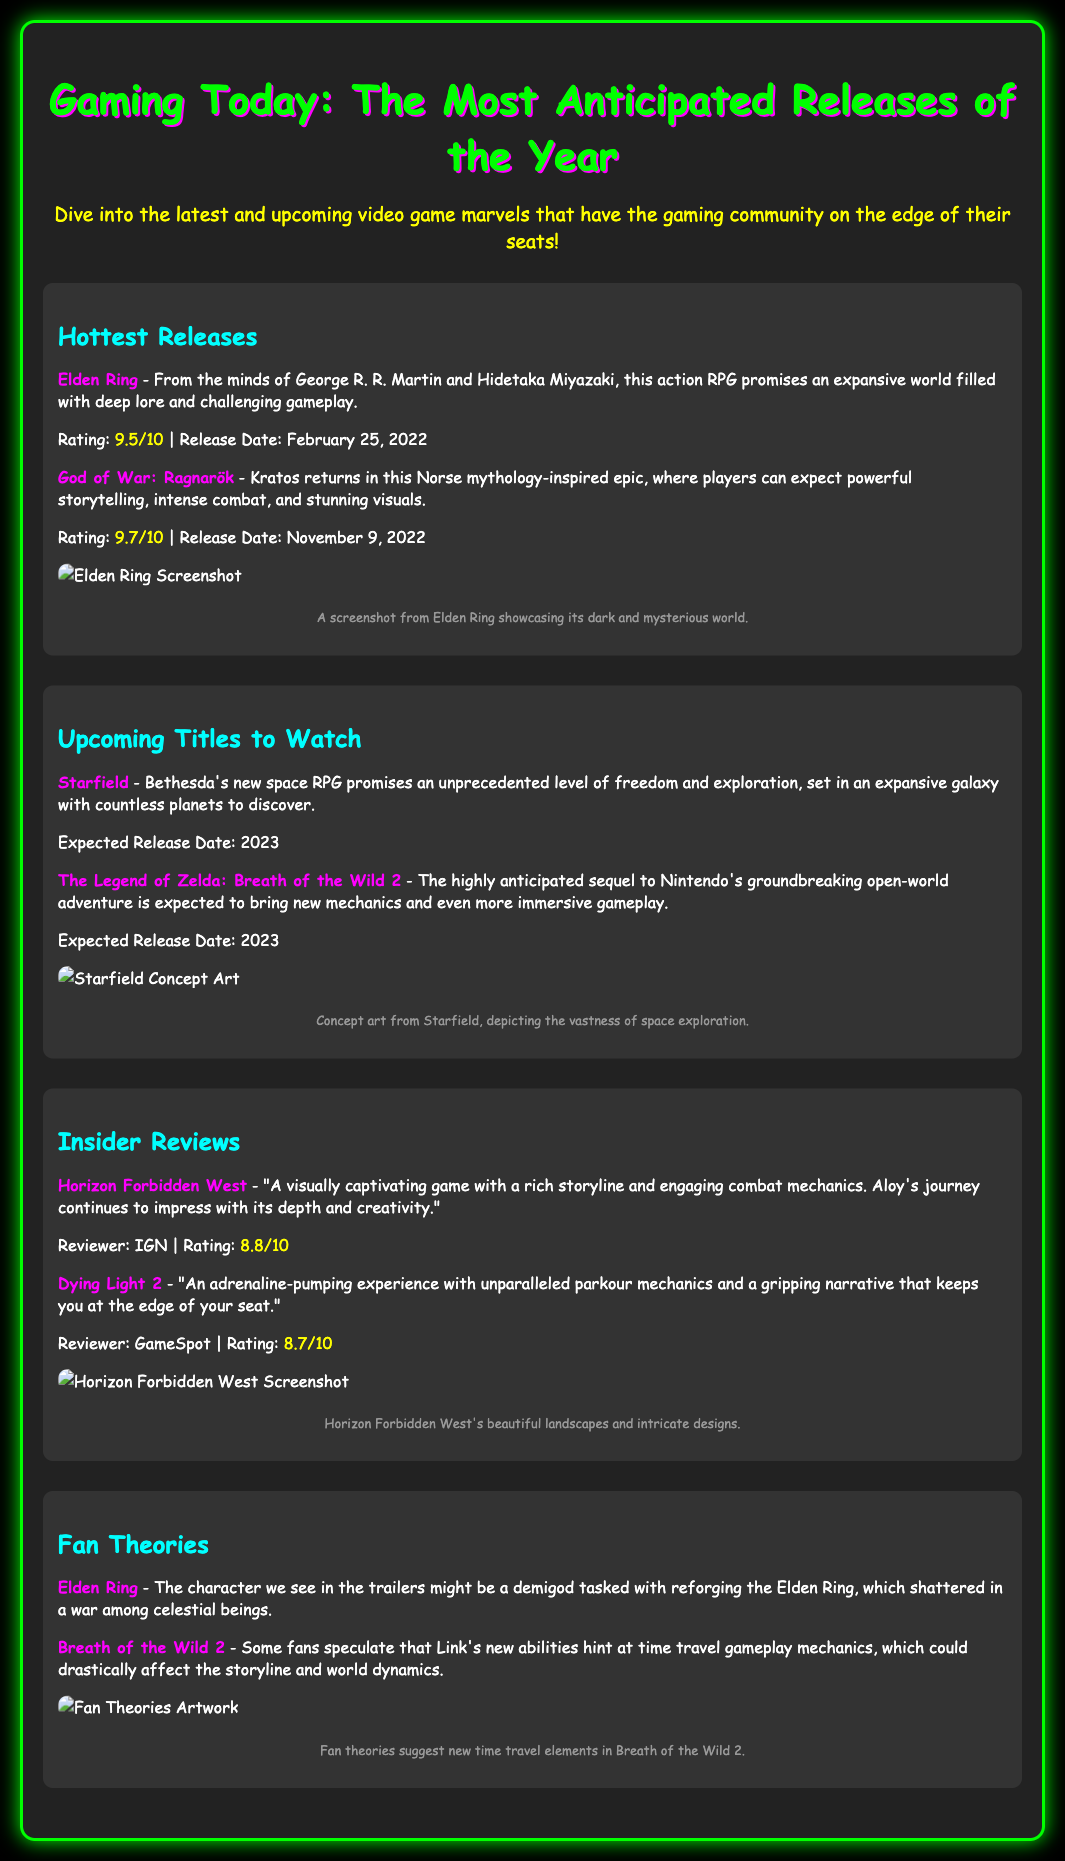what is the rating of God of War: Ragnarök? The rating is explicitly stated alongside the game title in the document.
Answer: 9.7/10 what game is described as a space RPG? This information is found in the section detailing upcoming titles.
Answer: Starfield when was the release date for Elden Ring? The release date is mentioned in the context of the game's information.
Answer: February 25, 2022 which game's reviewer gave it a rating of 8.8/10? This information can be retrieved from the insider reviews section paired with the respective game title.
Answer: Horizon Forbidden West what is the expected release date for The Legend of Zelda: Breath of the Wild 2? The expected release date is specified next to the title in the document.
Answer: 2023 what is the theme of the fan theory related to Breath of the Wild 2? The theory is described, revealing a potential gameplay mechanic discussed by fans.
Answer: time travel what type of game is Elden Ring characterized as? This is found in the description provided for the game in the document.
Answer: action RPG what is the main focus of the "Insider Reviews" section? This section highlights opinions and evaluations of certain games.
Answer: reviews how are games presented in the "Hottest Releases" section? This section categorizes the games based on their release status and provides ratings.
Answer: hottest releases 